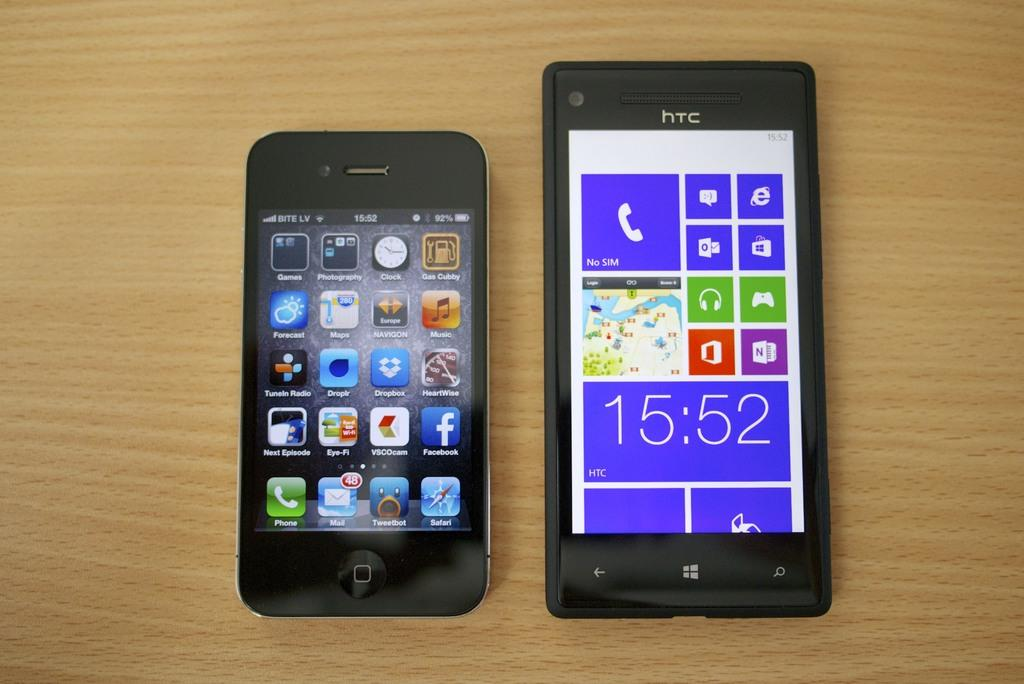<image>
Present a compact description of the photo's key features. Two mobile phones lay on a wooden surface with oine showing an Android home page and the other a Windows screen. 